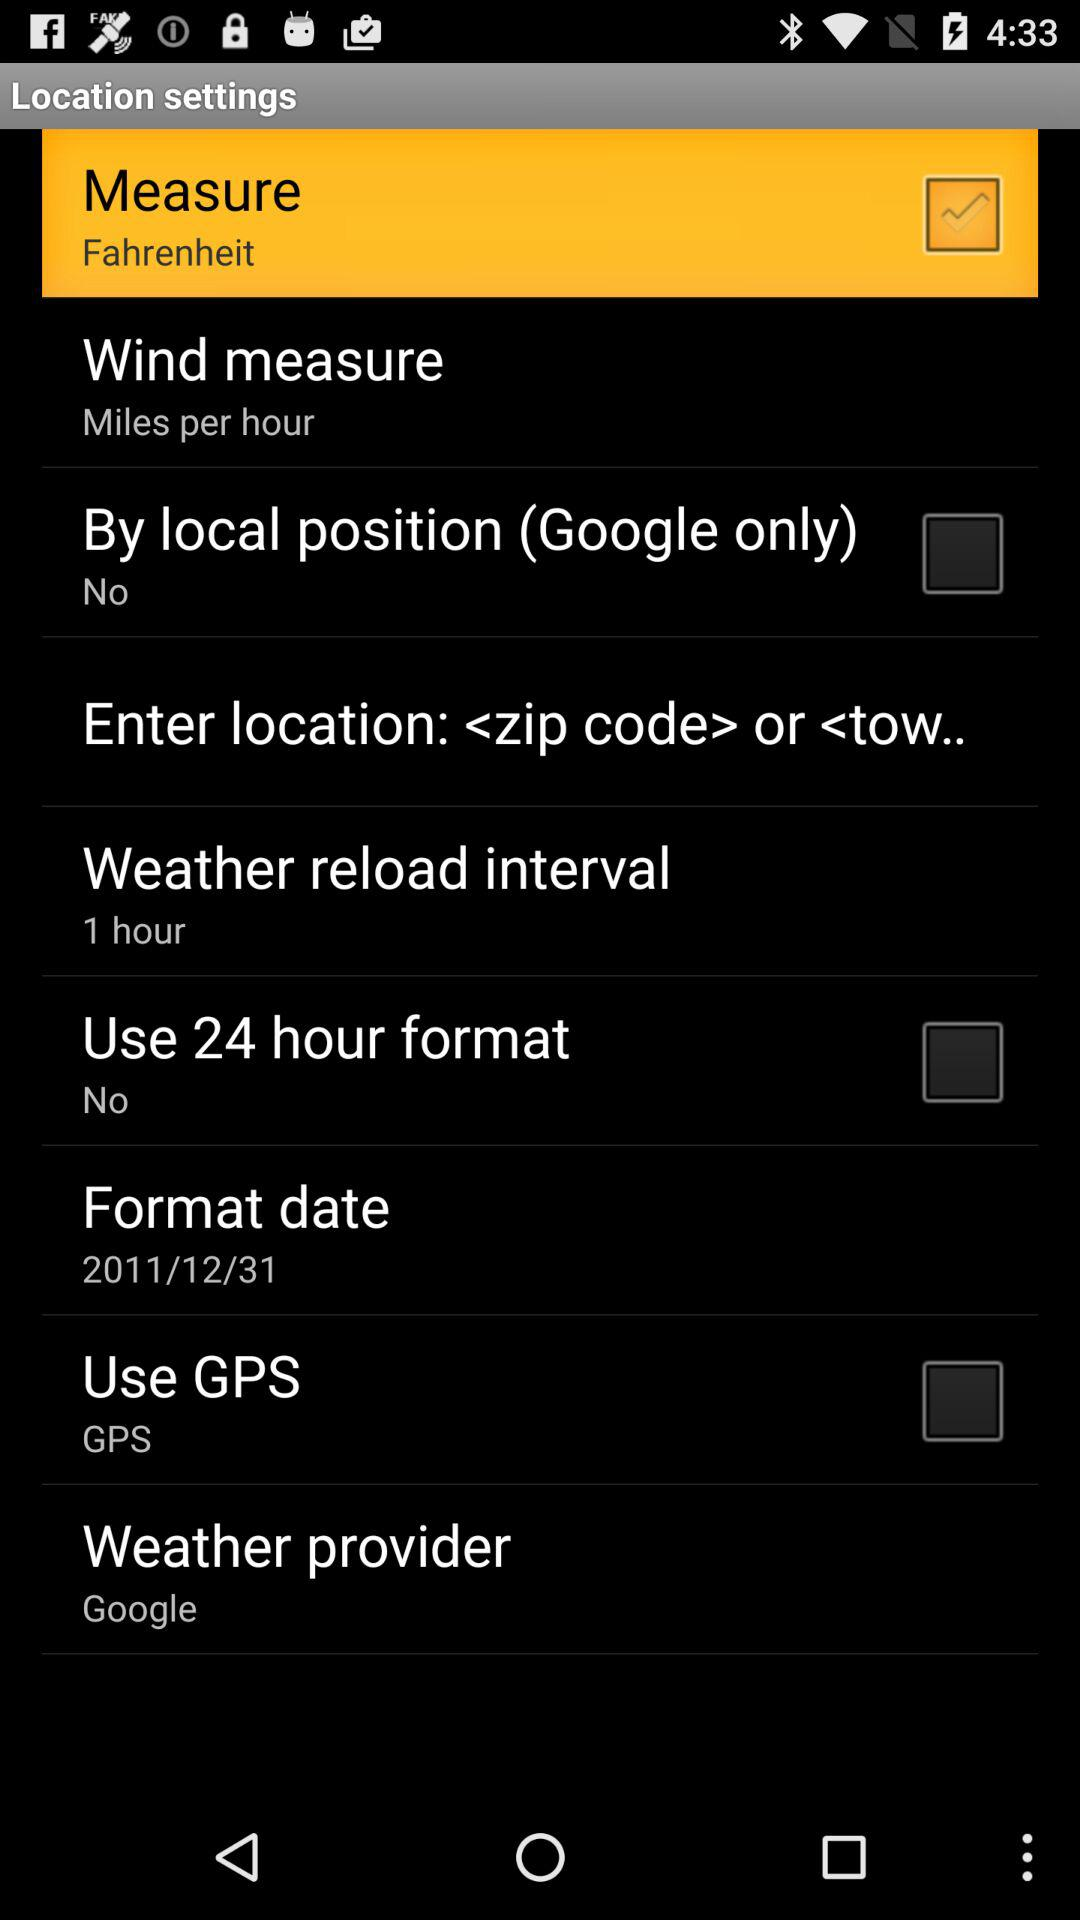Which of the checkboxes has been selected? The checkbox that has been selected is "Measure". 